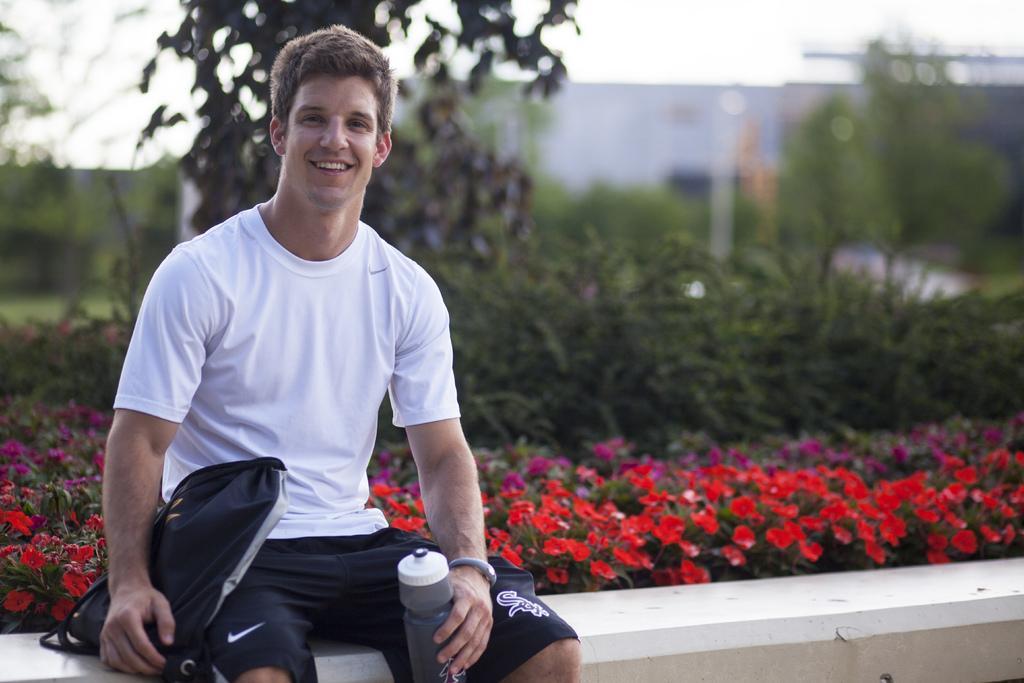Can you describe this image briefly? On the left side a man is sitting on a platform and holding a bag and a water bottle in his hands. In the background there are plants with flowers, trees, building and sky. 